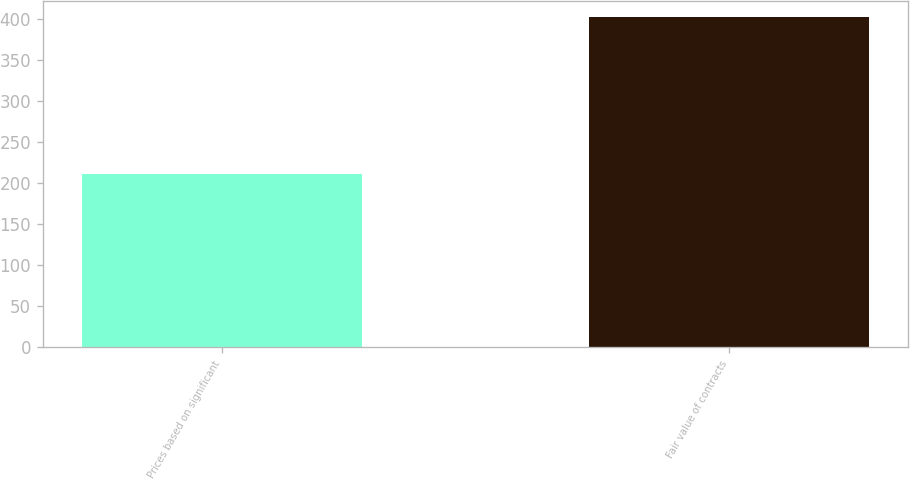<chart> <loc_0><loc_0><loc_500><loc_500><bar_chart><fcel>Prices based on significant<fcel>Fair value of contracts<nl><fcel>210.3<fcel>402<nl></chart> 